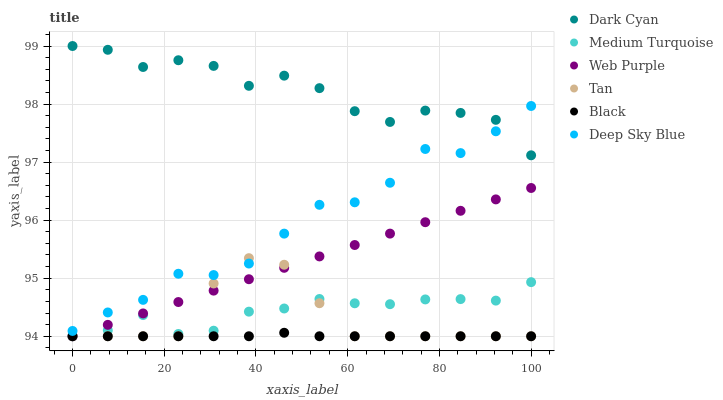Does Black have the minimum area under the curve?
Answer yes or no. Yes. Does Dark Cyan have the maximum area under the curve?
Answer yes or no. Yes. Does Web Purple have the minimum area under the curve?
Answer yes or no. No. Does Web Purple have the maximum area under the curve?
Answer yes or no. No. Is Web Purple the smoothest?
Answer yes or no. Yes. Is Dark Cyan the roughest?
Answer yes or no. Yes. Is Black the smoothest?
Answer yes or no. No. Is Black the roughest?
Answer yes or no. No. Does Medium Turquoise have the lowest value?
Answer yes or no. Yes. Does Deep Sky Blue have the lowest value?
Answer yes or no. No. Does Dark Cyan have the highest value?
Answer yes or no. Yes. Does Web Purple have the highest value?
Answer yes or no. No. Is Medium Turquoise less than Dark Cyan?
Answer yes or no. Yes. Is Dark Cyan greater than Medium Turquoise?
Answer yes or no. Yes. Does Black intersect Medium Turquoise?
Answer yes or no. Yes. Is Black less than Medium Turquoise?
Answer yes or no. No. Is Black greater than Medium Turquoise?
Answer yes or no. No. Does Medium Turquoise intersect Dark Cyan?
Answer yes or no. No. 